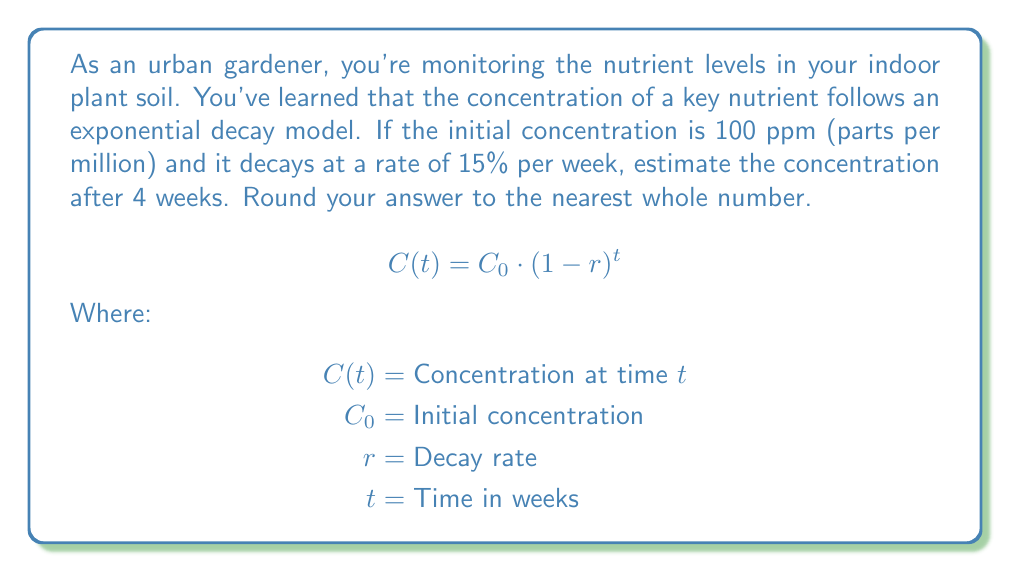Teach me how to tackle this problem. To solve this problem, we'll use the exponential decay formula:

$$C(t) = C_0 \cdot (1-r)^t$$

Given:
$C_0 = 100$ ppm (initial concentration)
$r = 0.15$ (15% decay rate)
$t = 4$ weeks

Let's substitute these values into the formula:

$$C(4) = 100 \cdot (1-0.15)^4$$

Now, let's solve step by step:

1) First, calculate $(1-0.15)$:
   $1 - 0.15 = 0.85$

2) Now, we have:
   $$C(4) = 100 \cdot (0.85)^4$$

3) Calculate $(0.85)^4$:
   $(0.85)^4 \approx 0.5220$

4) Multiply by the initial concentration:
   $$C(4) = 100 \cdot 0.5220 \approx 52.20$$

5) Round to the nearest whole number:
   $52.20 \approx 52$ ppm

Therefore, after 4 weeks, the estimated nutrient concentration is 52 ppm.
Answer: 52 ppm 